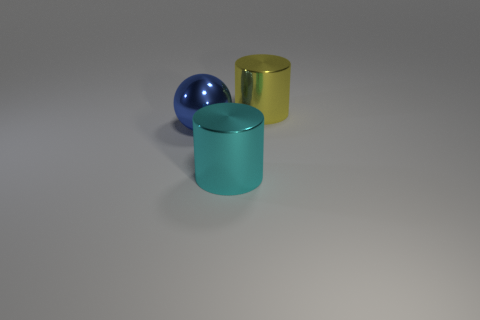Add 2 large yellow metallic things. How many objects exist? 5 Subtract all cylinders. How many objects are left? 1 Subtract 0 green balls. How many objects are left? 3 Subtract all small gray metallic spheres. Subtract all large yellow shiny things. How many objects are left? 2 Add 1 big cylinders. How many big cylinders are left? 3 Add 2 big cyan objects. How many big cyan objects exist? 3 